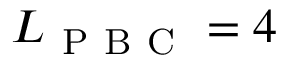<formula> <loc_0><loc_0><loc_500><loc_500>L _ { P B C } = 4</formula> 